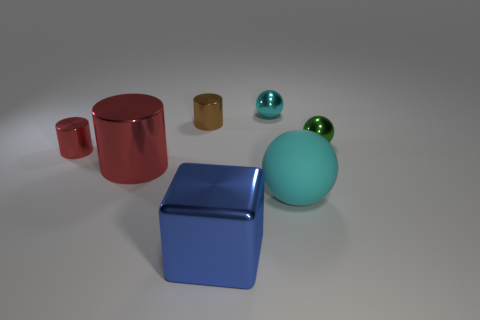How many red cylinders must be subtracted to get 1 red cylinders? 1 Subtract all small metallic spheres. How many spheres are left? 1 Subtract all gray spheres. How many red cylinders are left? 2 Subtract 1 cylinders. How many cylinders are left? 2 Add 2 cyan matte balls. How many objects exist? 9 Subtract all balls. How many objects are left? 4 Subtract all purple cylinders. Subtract all gray balls. How many cylinders are left? 3 Add 5 cyan metallic spheres. How many cyan metallic spheres are left? 6 Add 5 large red metallic things. How many large red metallic things exist? 6 Subtract 0 blue balls. How many objects are left? 7 